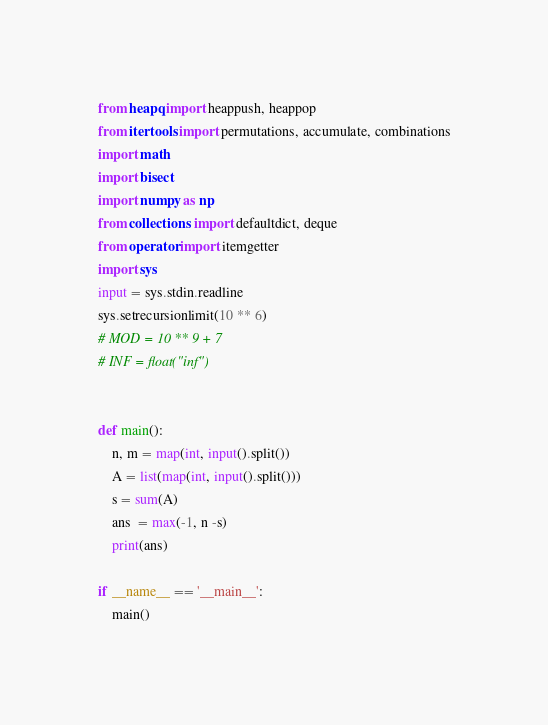<code> <loc_0><loc_0><loc_500><loc_500><_Python_>from heapq import heappush, heappop
from itertools import permutations, accumulate, combinations
import math
import bisect
import numpy as np
from collections import defaultdict, deque
from operator import itemgetter
import sys
input = sys.stdin.readline
sys.setrecursionlimit(10 ** 6)
# MOD = 10 ** 9 + 7
# INF = float("inf")


def main():
    n, m = map(int, input().split())
    A = list(map(int, input().split()))
    s = sum(A)
    ans  = max(-1, n -s)
    print(ans)

if __name__ == '__main__':
    main()</code> 